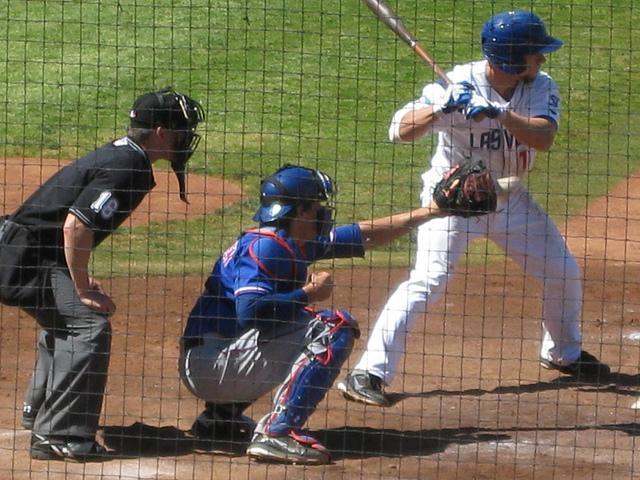How many people are there?
Give a very brief answer. 3. How many baseball gloves are in the photo?
Give a very brief answer. 1. 